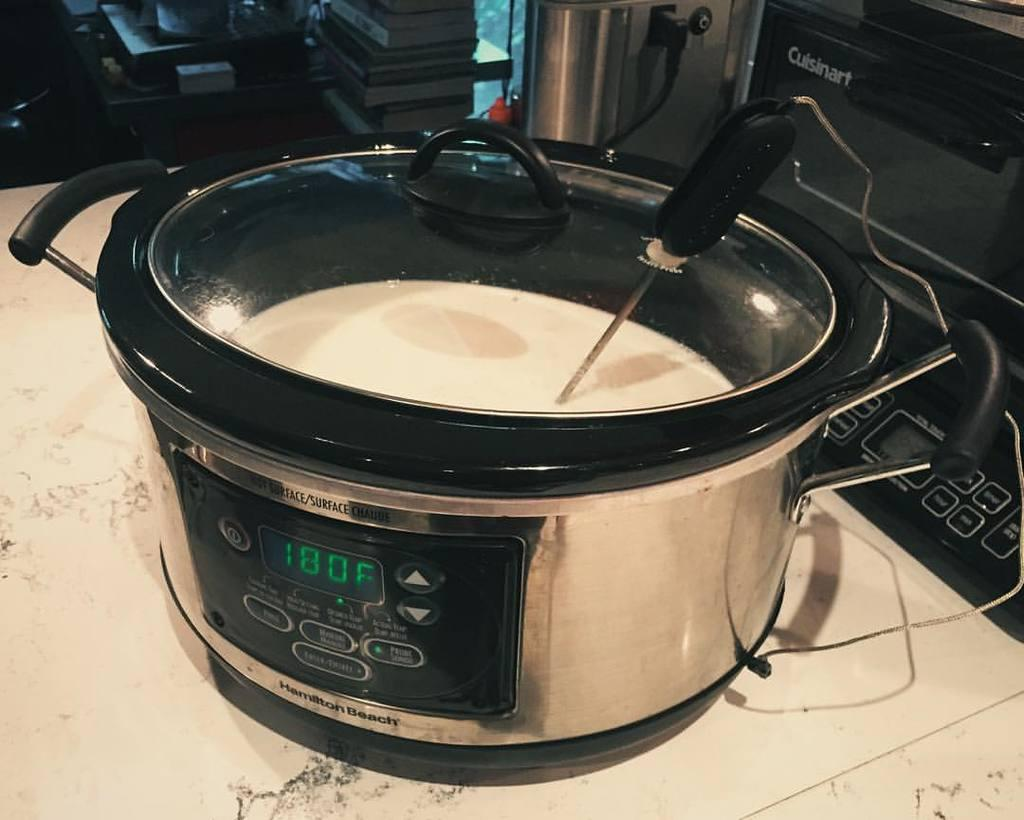<image>
Render a clear and concise summary of the photo. Crockpot with some yellow liquid inside and the current temperature at 180F. 